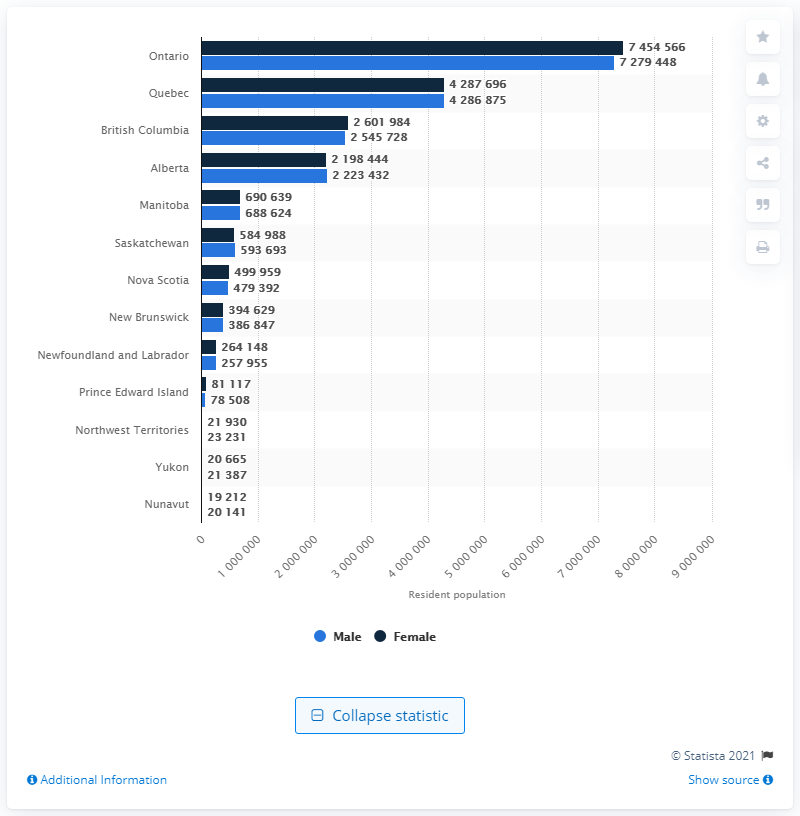Indicate a few pertinent items in this graphic. In 2020, the number of males living in British Columbia was approximately 254,5728. 